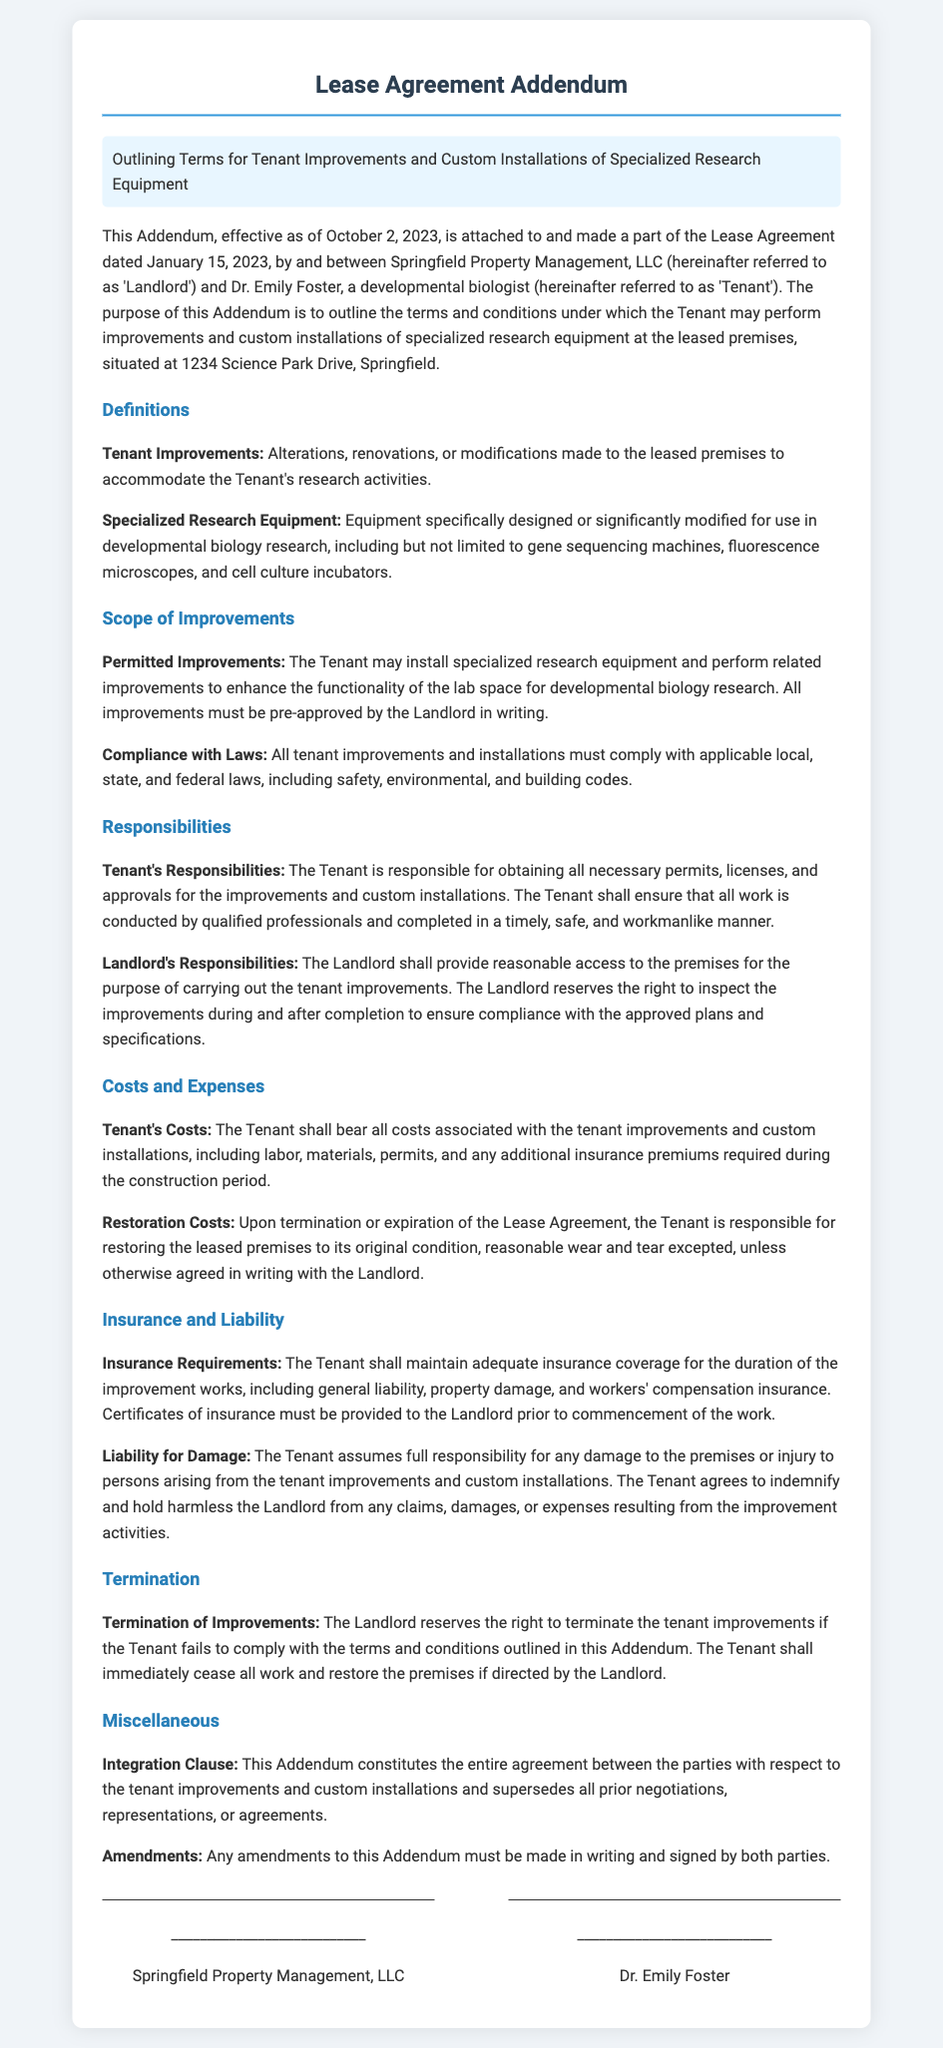what is the effective date of the addendum? The effective date of the addendum is stated at the beginning of the document.
Answer: October 2, 2023 who is the landlord? The landlord is identified in the introduction of the document.
Answer: Springfield Property Management, LLC what is defined as "Tenant Improvements"? The document provides a specific definition for "Tenant Improvements."
Answer: Alterations, renovations, or modifications made to the leased premises to accommodate the Tenant's research activities which responsibilities does the Tenant have? The section on responsibilities outlines what is required of the Tenant regarding improvements.
Answer: Obtaining all necessary permits, licenses, and approvals what does the Tenant need to maintain for insurance? The insurance requirements section indicates what the Tenant must maintain during improvements.
Answer: Adequate insurance coverage who must sign any amendments to the addendum? The document specifies who must sign any amendments for them to be valid.
Answer: Both parties what happens if the Tenant fails to comply with the terms? The document describes the consequence of non-compliance by the Tenant.
Answer: The Landlord reserves the right to terminate the tenant improvements what is the purpose of the addendum? The introduction of the document highlights the main goal of the addendum.
Answer: To outline the terms and conditions under which the Tenant may perform improvements and custom installations 